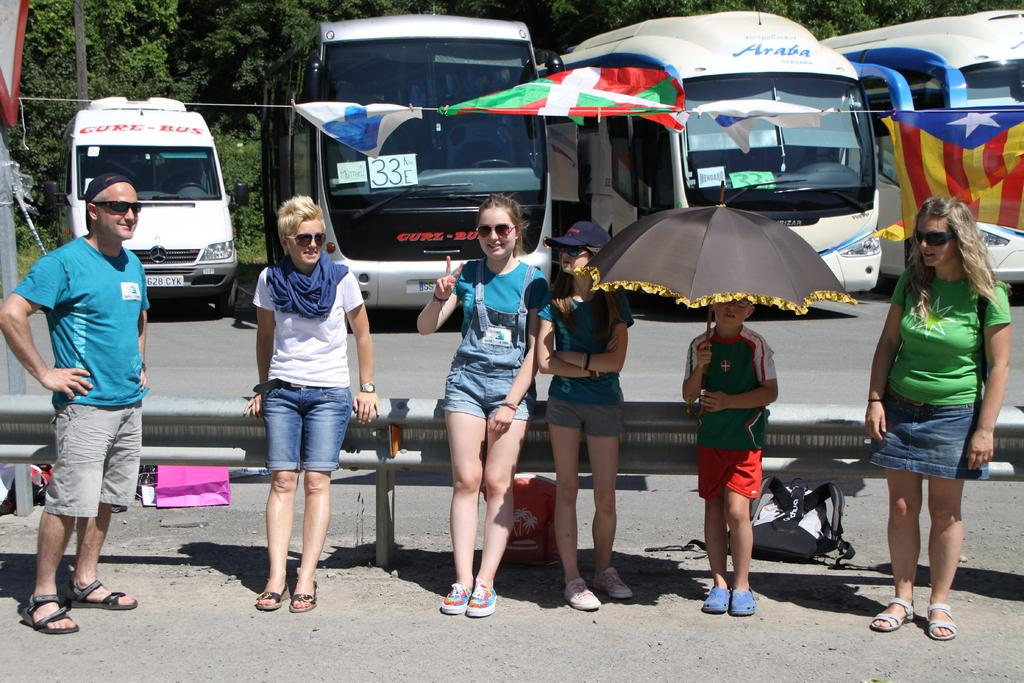How many people are in the group visible in the image? There is a group of people in the image, but the exact number is not specified. Where are the people located in the image? The people are standing in the front of the image. What can be seen behind the group of people in the image? There are four vehicles parked beside the road in the image. How are the vehicles positioned in relation to the group of people? The vehicles are behind the group of people. What type of vegetation is visible in the background of the image? There are many trees visible behind the vehicles in the image. What type of doll is causing anger among the group of people in the image? There is no doll or indication of anger present in the image. 